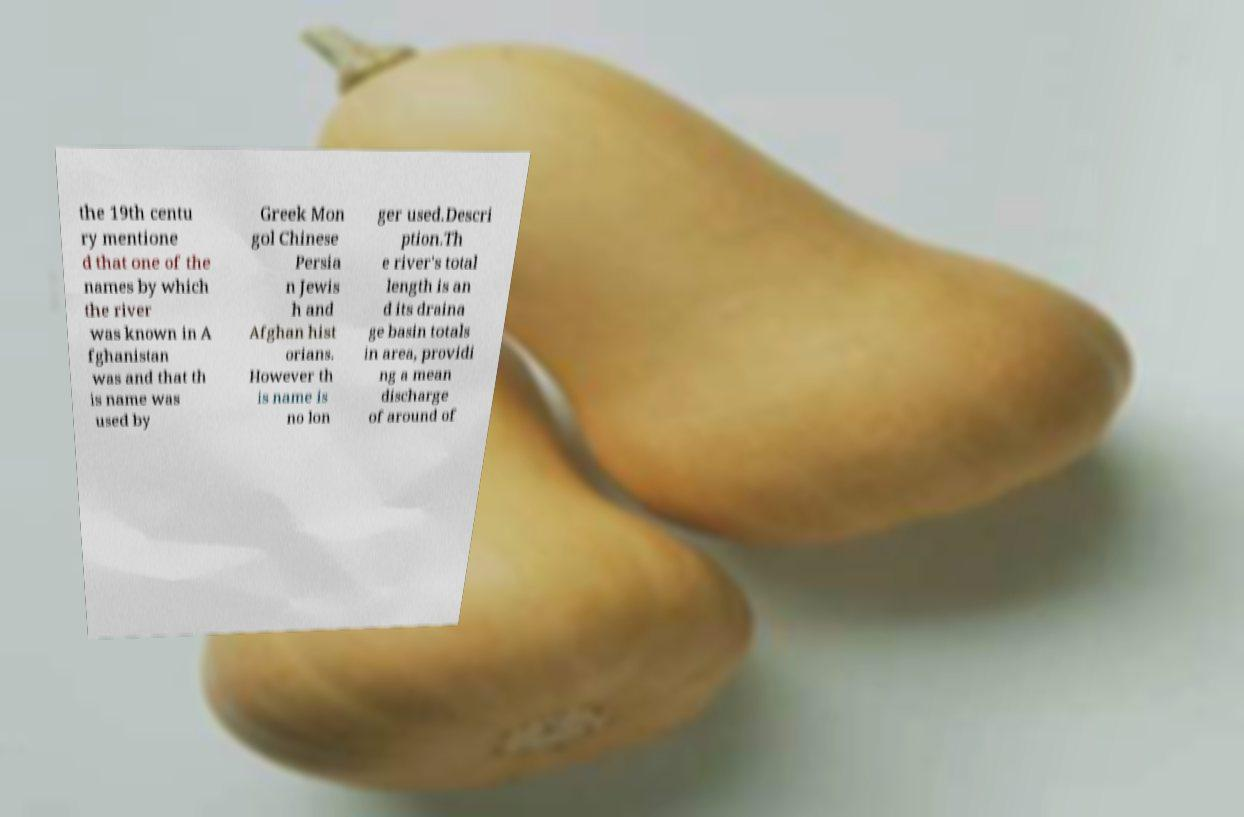There's text embedded in this image that I need extracted. Can you transcribe it verbatim? the 19th centu ry mentione d that one of the names by which the river was known in A fghanistan was and that th is name was used by Greek Mon gol Chinese Persia n Jewis h and Afghan hist orians. However th is name is no lon ger used.Descri ption.Th e river's total length is an d its draina ge basin totals in area, providi ng a mean discharge of around of 